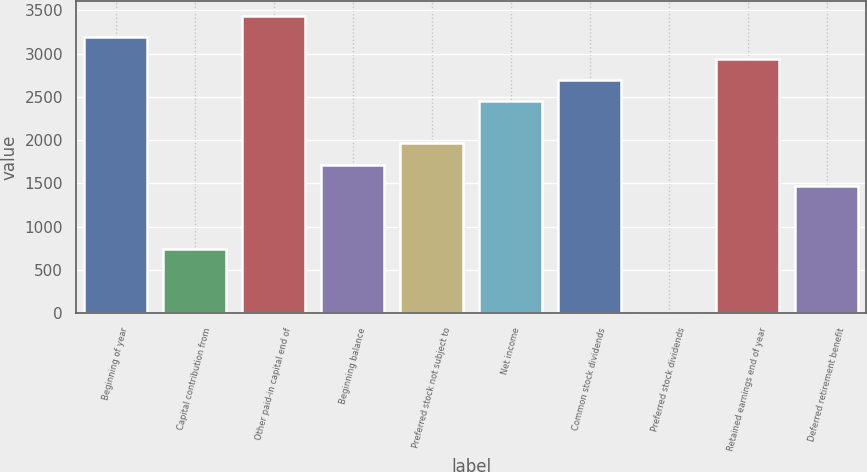<chart> <loc_0><loc_0><loc_500><loc_500><bar_chart><fcel>Beginning of year<fcel>Capital contribution from<fcel>Other paid-in capital end of<fcel>Beginning balance<fcel>Preferred stock not subject to<fcel>Net income<fcel>Common stock dividends<fcel>Preferred stock dividends<fcel>Retained earnings end of year<fcel>Deferred retirement benefit<nl><fcel>3186.7<fcel>737.7<fcel>3431.6<fcel>1717.3<fcel>1962.2<fcel>2452<fcel>2696.9<fcel>3<fcel>2941.8<fcel>1472.4<nl></chart> 